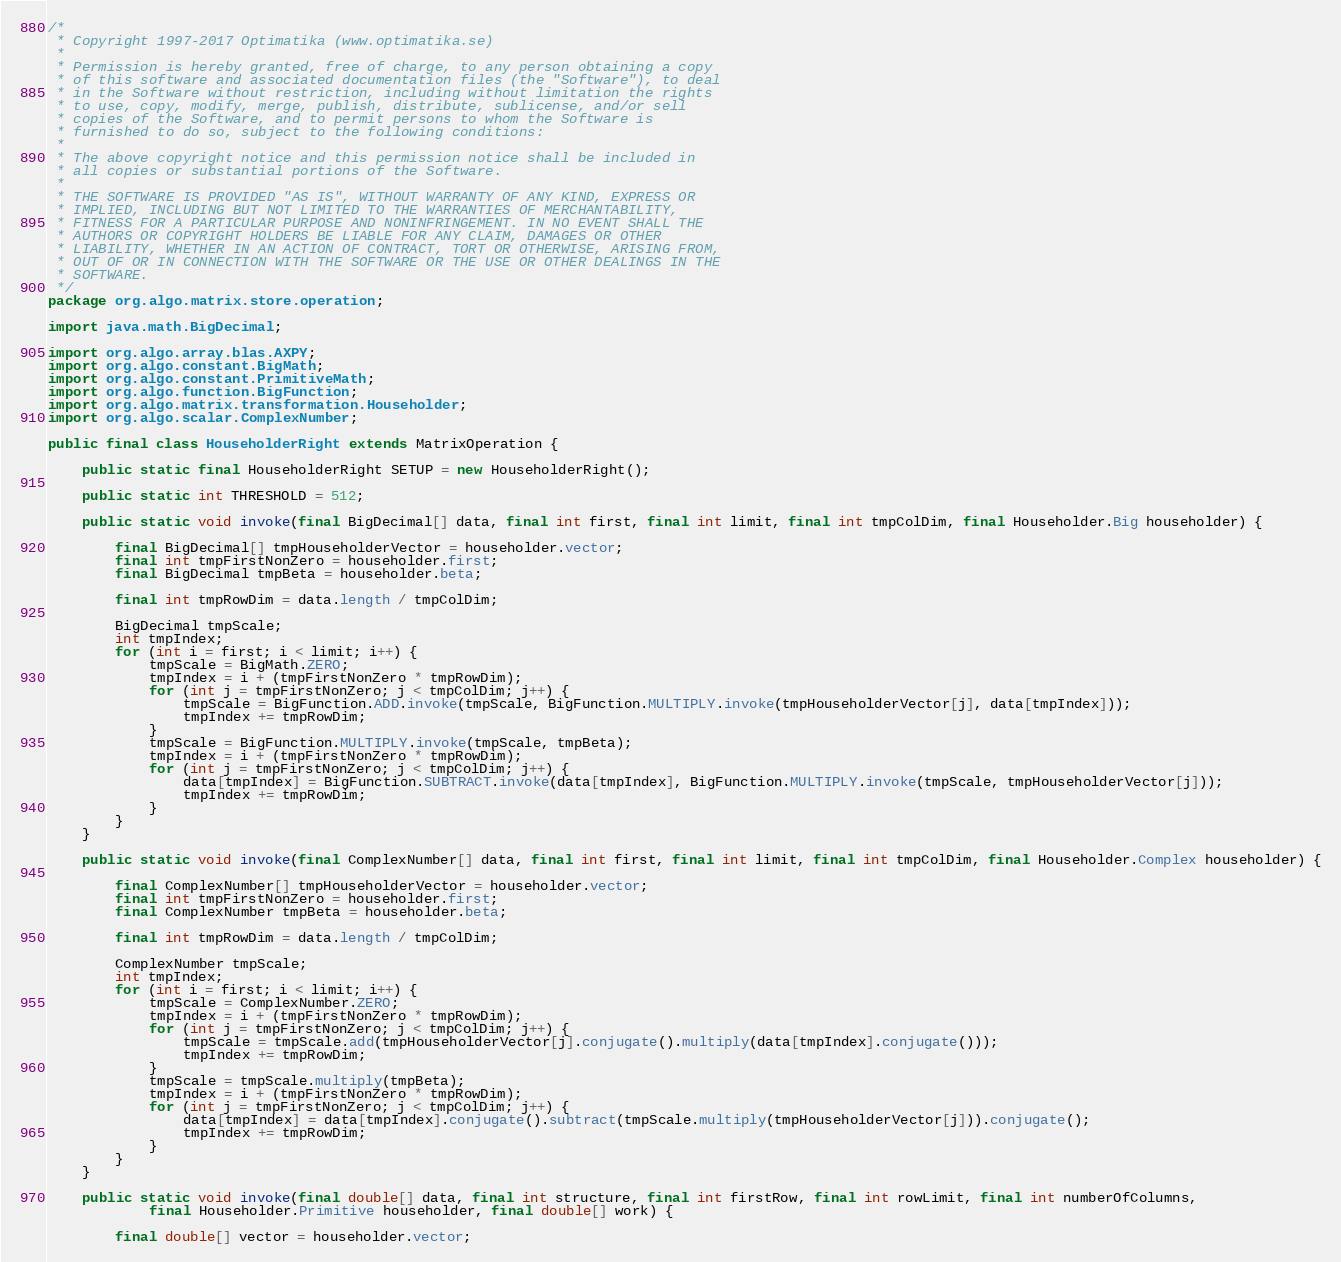Convert code to text. <code><loc_0><loc_0><loc_500><loc_500><_Java_>/*
 * Copyright 1997-2017 Optimatika (www.optimatika.se)
 *
 * Permission is hereby granted, free of charge, to any person obtaining a copy
 * of this software and associated documentation files (the "Software"), to deal
 * in the Software without restriction, including without limitation the rights
 * to use, copy, modify, merge, publish, distribute, sublicense, and/or sell
 * copies of the Software, and to permit persons to whom the Software is
 * furnished to do so, subject to the following conditions:
 *
 * The above copyright notice and this permission notice shall be included in
 * all copies or substantial portions of the Software.
 *
 * THE SOFTWARE IS PROVIDED "AS IS", WITHOUT WARRANTY OF ANY KIND, EXPRESS OR
 * IMPLIED, INCLUDING BUT NOT LIMITED TO THE WARRANTIES OF MERCHANTABILITY,
 * FITNESS FOR A PARTICULAR PURPOSE AND NONINFRINGEMENT. IN NO EVENT SHALL THE
 * AUTHORS OR COPYRIGHT HOLDERS BE LIABLE FOR ANY CLAIM, DAMAGES OR OTHER
 * LIABILITY, WHETHER IN AN ACTION OF CONTRACT, TORT OR OTHERWISE, ARISING FROM,
 * OUT OF OR IN CONNECTION WITH THE SOFTWARE OR THE USE OR OTHER DEALINGS IN THE
 * SOFTWARE.
 */
package org.algo.matrix.store.operation;

import java.math.BigDecimal;

import org.algo.array.blas.AXPY;
import org.algo.constant.BigMath;
import org.algo.constant.PrimitiveMath;
import org.algo.function.BigFunction;
import org.algo.matrix.transformation.Householder;
import org.algo.scalar.ComplexNumber;

public final class HouseholderRight extends MatrixOperation {

    public static final HouseholderRight SETUP = new HouseholderRight();

    public static int THRESHOLD = 512;

    public static void invoke(final BigDecimal[] data, final int first, final int limit, final int tmpColDim, final Householder.Big householder) {

        final BigDecimal[] tmpHouseholderVector = householder.vector;
        final int tmpFirstNonZero = householder.first;
        final BigDecimal tmpBeta = householder.beta;

        final int tmpRowDim = data.length / tmpColDim;

        BigDecimal tmpScale;
        int tmpIndex;
        for (int i = first; i < limit; i++) {
            tmpScale = BigMath.ZERO;
            tmpIndex = i + (tmpFirstNonZero * tmpRowDim);
            for (int j = tmpFirstNonZero; j < tmpColDim; j++) {
                tmpScale = BigFunction.ADD.invoke(tmpScale, BigFunction.MULTIPLY.invoke(tmpHouseholderVector[j], data[tmpIndex]));
                tmpIndex += tmpRowDim;
            }
            tmpScale = BigFunction.MULTIPLY.invoke(tmpScale, tmpBeta);
            tmpIndex = i + (tmpFirstNonZero * tmpRowDim);
            for (int j = tmpFirstNonZero; j < tmpColDim; j++) {
                data[tmpIndex] = BigFunction.SUBTRACT.invoke(data[tmpIndex], BigFunction.MULTIPLY.invoke(tmpScale, tmpHouseholderVector[j]));
                tmpIndex += tmpRowDim;
            }
        }
    }

    public static void invoke(final ComplexNumber[] data, final int first, final int limit, final int tmpColDim, final Householder.Complex householder) {

        final ComplexNumber[] tmpHouseholderVector = householder.vector;
        final int tmpFirstNonZero = householder.first;
        final ComplexNumber tmpBeta = householder.beta;

        final int tmpRowDim = data.length / tmpColDim;

        ComplexNumber tmpScale;
        int tmpIndex;
        for (int i = first; i < limit; i++) {
            tmpScale = ComplexNumber.ZERO;
            tmpIndex = i + (tmpFirstNonZero * tmpRowDim);
            for (int j = tmpFirstNonZero; j < tmpColDim; j++) {
                tmpScale = tmpScale.add(tmpHouseholderVector[j].conjugate().multiply(data[tmpIndex].conjugate()));
                tmpIndex += tmpRowDim;
            }
            tmpScale = tmpScale.multiply(tmpBeta);
            tmpIndex = i + (tmpFirstNonZero * tmpRowDim);
            for (int j = tmpFirstNonZero; j < tmpColDim; j++) {
                data[tmpIndex] = data[tmpIndex].conjugate().subtract(tmpScale.multiply(tmpHouseholderVector[j])).conjugate();
                tmpIndex += tmpRowDim;
            }
        }
    }

    public static void invoke(final double[] data, final int structure, final int firstRow, final int rowLimit, final int numberOfColumns,
            final Householder.Primitive householder, final double[] work) {

        final double[] vector = householder.vector;</code> 